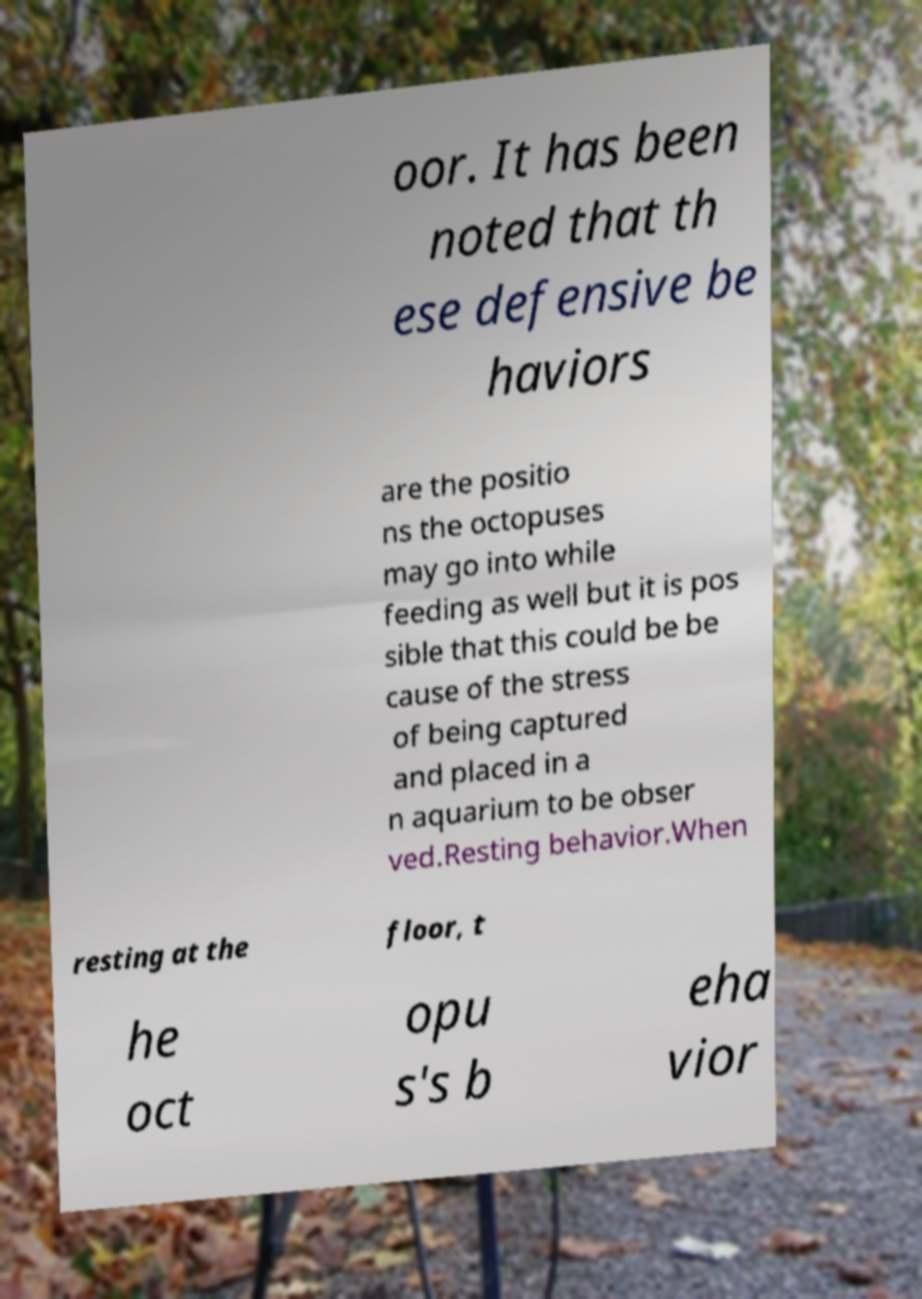There's text embedded in this image that I need extracted. Can you transcribe it verbatim? oor. It has been noted that th ese defensive be haviors are the positio ns the octopuses may go into while feeding as well but it is pos sible that this could be be cause of the stress of being captured and placed in a n aquarium to be obser ved.Resting behavior.When resting at the floor, t he oct opu s's b eha vior 